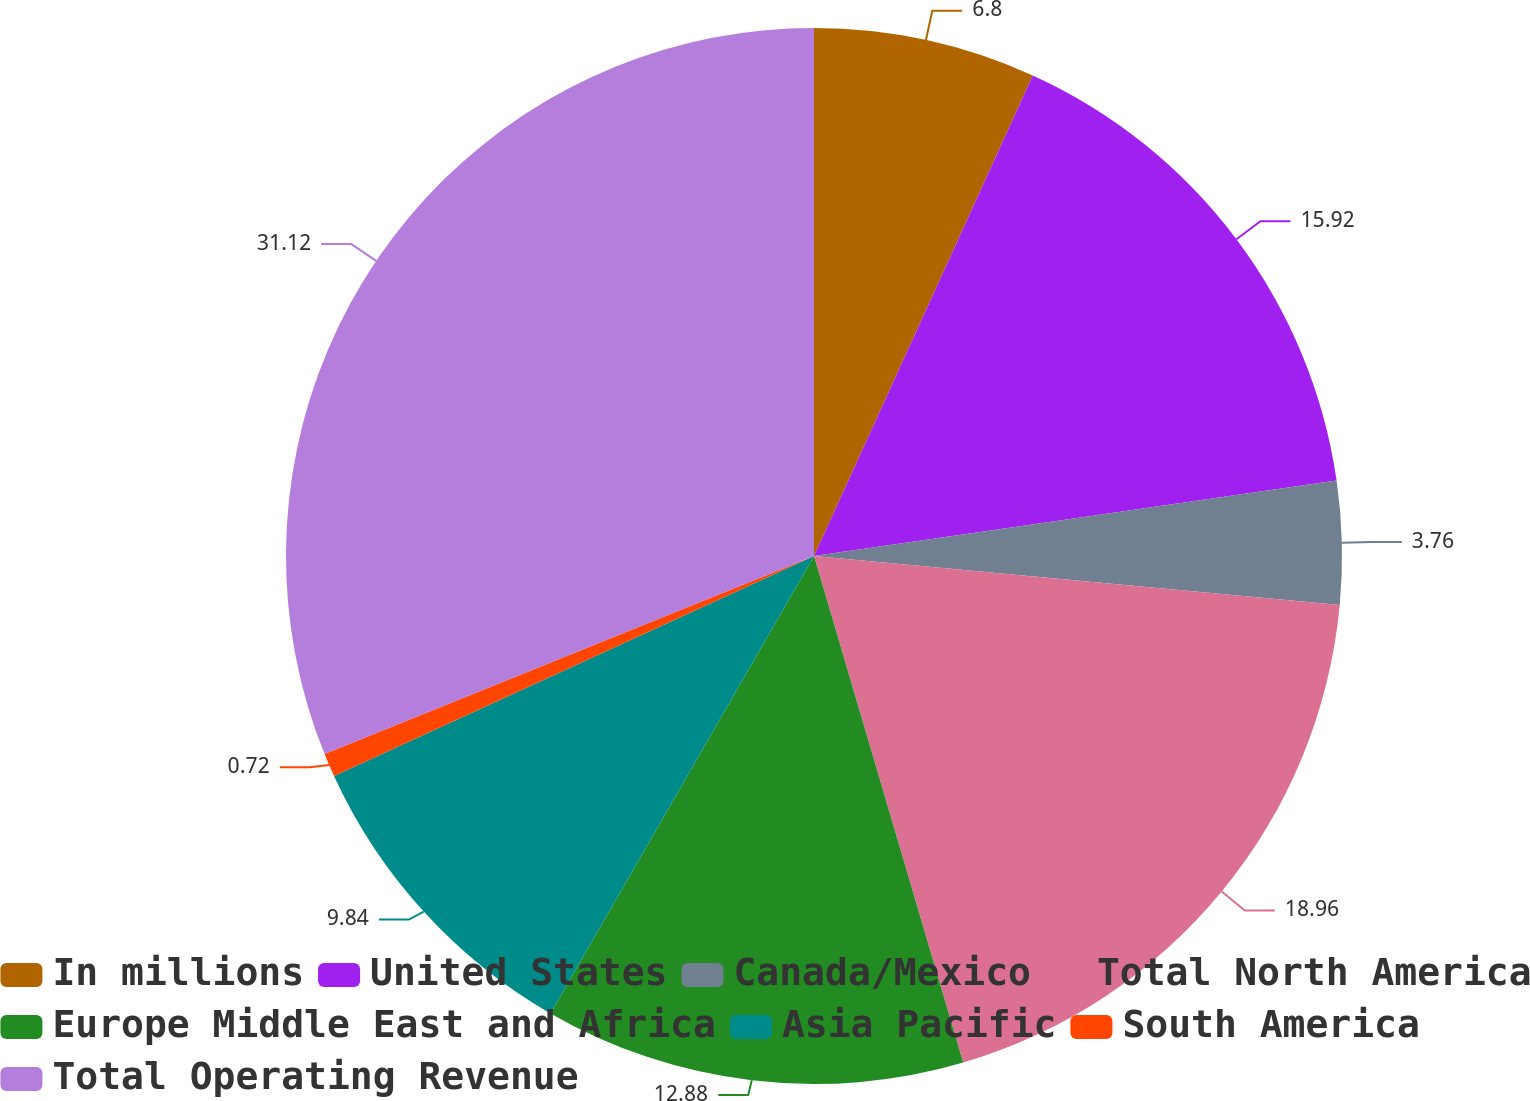Convert chart to OTSL. <chart><loc_0><loc_0><loc_500><loc_500><pie_chart><fcel>In millions<fcel>United States<fcel>Canada/Mexico<fcel>Total North America<fcel>Europe Middle East and Africa<fcel>Asia Pacific<fcel>South America<fcel>Total Operating Revenue<nl><fcel>6.8%<fcel>15.92%<fcel>3.76%<fcel>18.96%<fcel>12.88%<fcel>9.84%<fcel>0.72%<fcel>31.12%<nl></chart> 